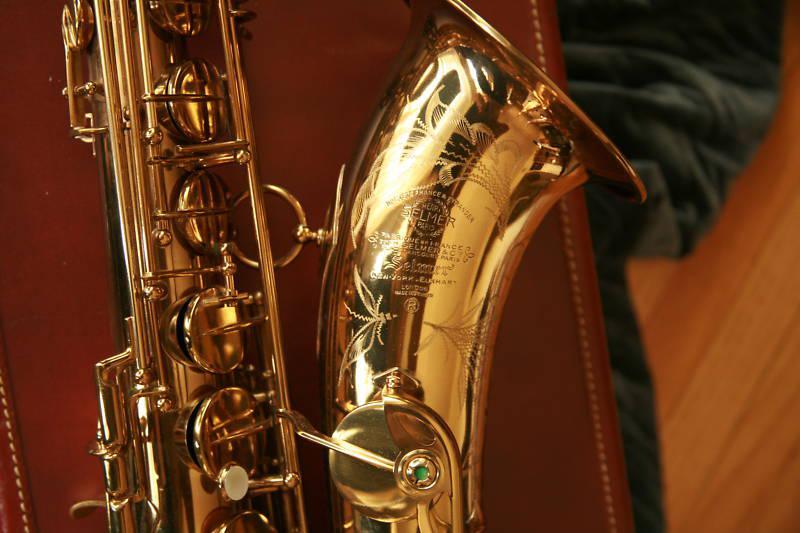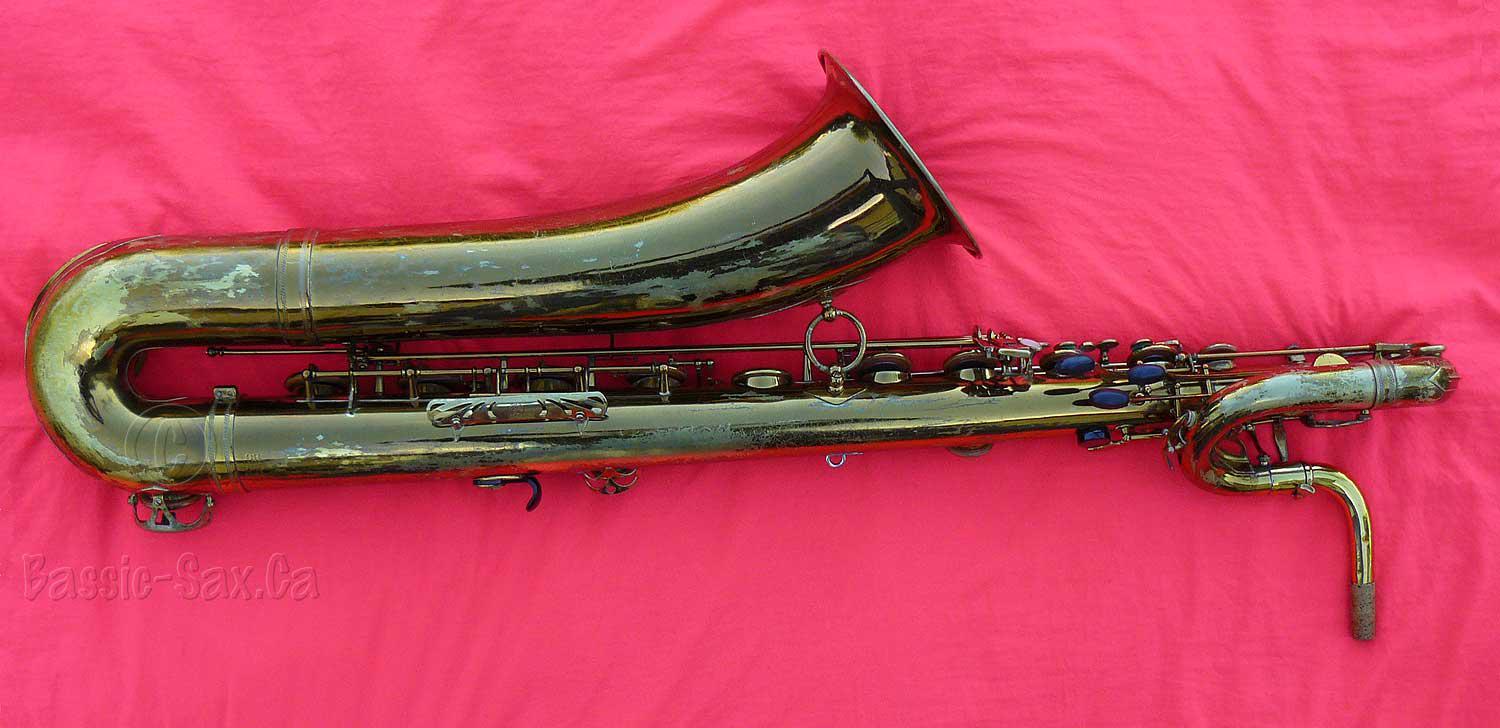The first image is the image on the left, the second image is the image on the right. Given the left and right images, does the statement "Has an image with more than one kind of saxophone." hold true? Answer yes or no. No. The first image is the image on the left, the second image is the image on the right. Given the left and right images, does the statement "At least one image shows a straight instrument displayed next to a saxophone with a curved bell and mouthpiece." hold true? Answer yes or no. No. 